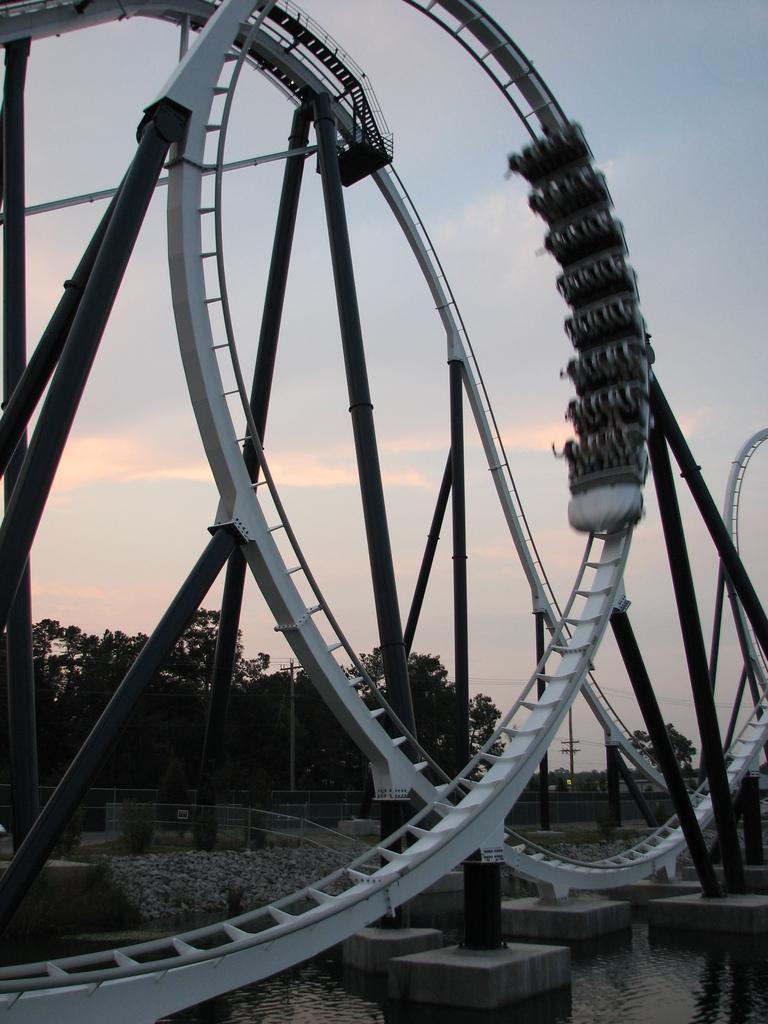In one or two sentences, can you explain what this image depicts? In this picture we can see a roll a coaster ride. We can see a few poles and water. There are a few trees visible in the background. 